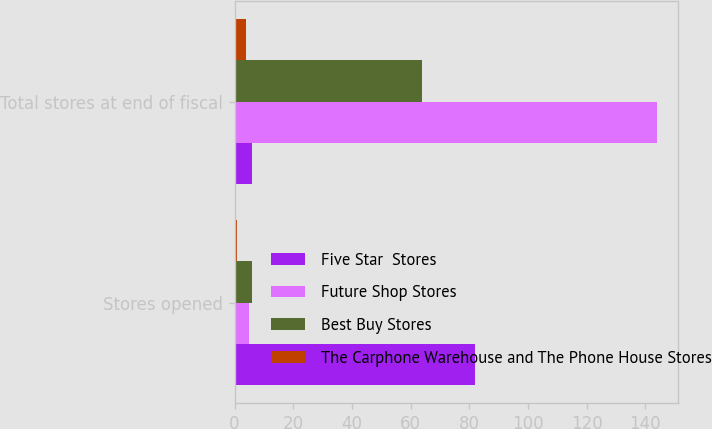Convert chart. <chart><loc_0><loc_0><loc_500><loc_500><stacked_bar_chart><ecel><fcel>Stores opened<fcel>Total stores at end of fiscal<nl><fcel>Five Star  Stores<fcel>82<fcel>6<nl><fcel>Future Shop Stores<fcel>5<fcel>144<nl><fcel>Best Buy Stores<fcel>6<fcel>64<nl><fcel>The Carphone Warehouse and The Phone House Stores<fcel>1<fcel>4<nl></chart> 